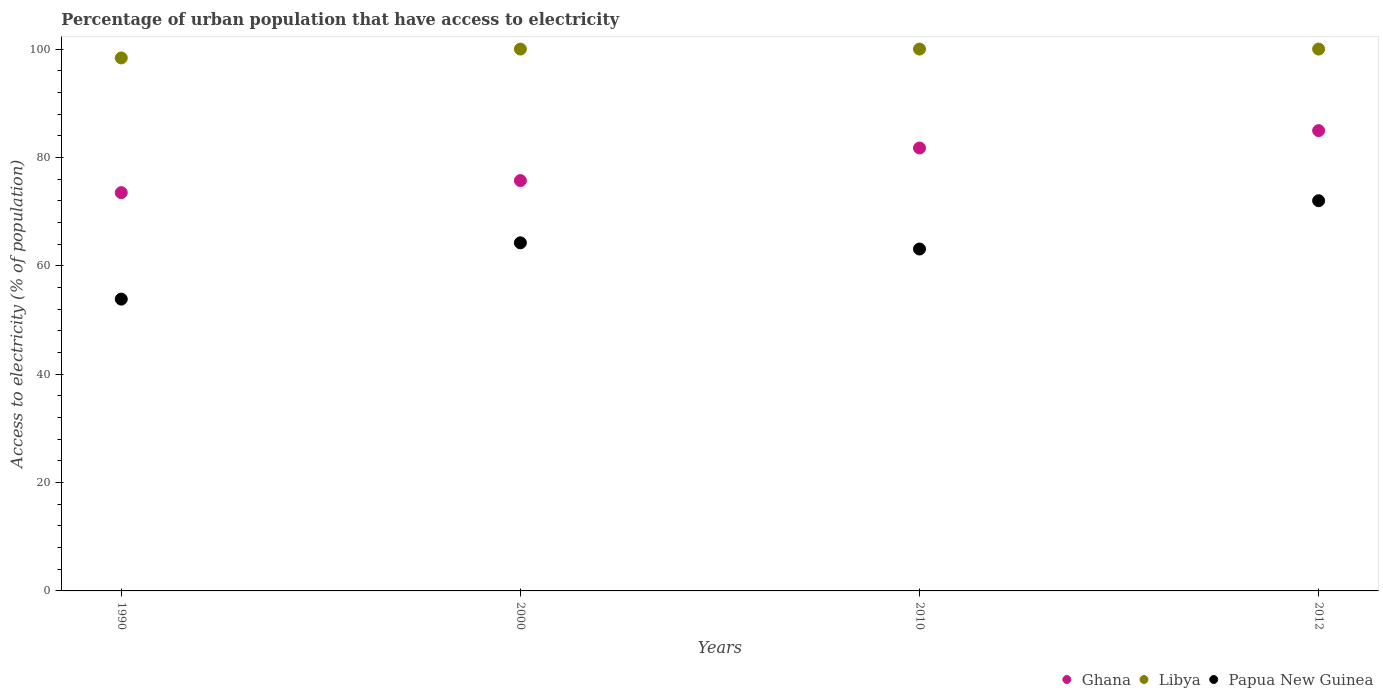How many different coloured dotlines are there?
Make the answer very short. 3. What is the percentage of urban population that have access to electricity in Papua New Guinea in 2010?
Your answer should be very brief. 63.1. Across all years, what is the maximum percentage of urban population that have access to electricity in Ghana?
Offer a terse response. 84.95. Across all years, what is the minimum percentage of urban population that have access to electricity in Ghana?
Offer a terse response. 73.51. In which year was the percentage of urban population that have access to electricity in Libya maximum?
Your answer should be very brief. 2000. In which year was the percentage of urban population that have access to electricity in Ghana minimum?
Your answer should be very brief. 1990. What is the total percentage of urban population that have access to electricity in Ghana in the graph?
Make the answer very short. 315.93. What is the difference between the percentage of urban population that have access to electricity in Ghana in 1990 and that in 2010?
Provide a succinct answer. -8.24. What is the difference between the percentage of urban population that have access to electricity in Ghana in 2000 and the percentage of urban population that have access to electricity in Papua New Guinea in 2010?
Ensure brevity in your answer.  12.63. What is the average percentage of urban population that have access to electricity in Papua New Guinea per year?
Keep it short and to the point. 63.3. In the year 1990, what is the difference between the percentage of urban population that have access to electricity in Libya and percentage of urban population that have access to electricity in Papua New Guinea?
Offer a terse response. 44.51. In how many years, is the percentage of urban population that have access to electricity in Papua New Guinea greater than 40 %?
Provide a short and direct response. 4. What is the ratio of the percentage of urban population that have access to electricity in Papua New Guinea in 1990 to that in 2010?
Offer a terse response. 0.85. What is the difference between the highest and the second highest percentage of urban population that have access to electricity in Libya?
Ensure brevity in your answer.  0. What is the difference between the highest and the lowest percentage of urban population that have access to electricity in Papua New Guinea?
Ensure brevity in your answer.  18.16. Is the sum of the percentage of urban population that have access to electricity in Ghana in 1990 and 2012 greater than the maximum percentage of urban population that have access to electricity in Libya across all years?
Your answer should be compact. Yes. Does the percentage of urban population that have access to electricity in Libya monotonically increase over the years?
Make the answer very short. No. How many years are there in the graph?
Ensure brevity in your answer.  4. What is the difference between two consecutive major ticks on the Y-axis?
Your response must be concise. 20. Are the values on the major ticks of Y-axis written in scientific E-notation?
Offer a very short reply. No. Does the graph contain any zero values?
Your response must be concise. No. Does the graph contain grids?
Your response must be concise. No. How many legend labels are there?
Your answer should be compact. 3. How are the legend labels stacked?
Provide a succinct answer. Horizontal. What is the title of the graph?
Offer a very short reply. Percentage of urban population that have access to electricity. What is the label or title of the Y-axis?
Keep it short and to the point. Access to electricity (% of population). What is the Access to electricity (% of population) of Ghana in 1990?
Provide a short and direct response. 73.51. What is the Access to electricity (% of population) of Libya in 1990?
Ensure brevity in your answer.  98.37. What is the Access to electricity (% of population) in Papua New Guinea in 1990?
Offer a terse response. 53.85. What is the Access to electricity (% of population) in Ghana in 2000?
Provide a succinct answer. 75.73. What is the Access to electricity (% of population) of Papua New Guinea in 2000?
Give a very brief answer. 64.25. What is the Access to electricity (% of population) in Ghana in 2010?
Provide a short and direct response. 81.74. What is the Access to electricity (% of population) of Papua New Guinea in 2010?
Make the answer very short. 63.1. What is the Access to electricity (% of population) in Ghana in 2012?
Make the answer very short. 84.95. What is the Access to electricity (% of population) of Libya in 2012?
Your answer should be very brief. 100. What is the Access to electricity (% of population) of Papua New Guinea in 2012?
Your response must be concise. 72.01. Across all years, what is the maximum Access to electricity (% of population) of Ghana?
Make the answer very short. 84.95. Across all years, what is the maximum Access to electricity (% of population) of Papua New Guinea?
Provide a short and direct response. 72.01. Across all years, what is the minimum Access to electricity (% of population) of Ghana?
Make the answer very short. 73.51. Across all years, what is the minimum Access to electricity (% of population) in Libya?
Keep it short and to the point. 98.37. Across all years, what is the minimum Access to electricity (% of population) in Papua New Guinea?
Ensure brevity in your answer.  53.85. What is the total Access to electricity (% of population) of Ghana in the graph?
Provide a succinct answer. 315.93. What is the total Access to electricity (% of population) of Libya in the graph?
Your answer should be very brief. 398.37. What is the total Access to electricity (% of population) in Papua New Guinea in the graph?
Give a very brief answer. 253.22. What is the difference between the Access to electricity (% of population) of Ghana in 1990 and that in 2000?
Offer a terse response. -2.22. What is the difference between the Access to electricity (% of population) of Libya in 1990 and that in 2000?
Your response must be concise. -1.63. What is the difference between the Access to electricity (% of population) of Papua New Guinea in 1990 and that in 2000?
Your answer should be very brief. -10.39. What is the difference between the Access to electricity (% of population) of Ghana in 1990 and that in 2010?
Your answer should be compact. -8.24. What is the difference between the Access to electricity (% of population) of Libya in 1990 and that in 2010?
Keep it short and to the point. -1.63. What is the difference between the Access to electricity (% of population) in Papua New Guinea in 1990 and that in 2010?
Offer a very short reply. -9.25. What is the difference between the Access to electricity (% of population) of Ghana in 1990 and that in 2012?
Provide a short and direct response. -11.45. What is the difference between the Access to electricity (% of population) in Libya in 1990 and that in 2012?
Keep it short and to the point. -1.63. What is the difference between the Access to electricity (% of population) in Papua New Guinea in 1990 and that in 2012?
Provide a short and direct response. -18.16. What is the difference between the Access to electricity (% of population) in Ghana in 2000 and that in 2010?
Provide a succinct answer. -6.01. What is the difference between the Access to electricity (% of population) of Papua New Guinea in 2000 and that in 2010?
Offer a terse response. 1.14. What is the difference between the Access to electricity (% of population) in Ghana in 2000 and that in 2012?
Your response must be concise. -9.22. What is the difference between the Access to electricity (% of population) in Libya in 2000 and that in 2012?
Provide a short and direct response. 0. What is the difference between the Access to electricity (% of population) of Papua New Guinea in 2000 and that in 2012?
Provide a succinct answer. -7.77. What is the difference between the Access to electricity (% of population) in Ghana in 2010 and that in 2012?
Your answer should be compact. -3.21. What is the difference between the Access to electricity (% of population) of Libya in 2010 and that in 2012?
Offer a very short reply. 0. What is the difference between the Access to electricity (% of population) of Papua New Guinea in 2010 and that in 2012?
Keep it short and to the point. -8.91. What is the difference between the Access to electricity (% of population) of Ghana in 1990 and the Access to electricity (% of population) of Libya in 2000?
Give a very brief answer. -26.49. What is the difference between the Access to electricity (% of population) of Ghana in 1990 and the Access to electricity (% of population) of Papua New Guinea in 2000?
Ensure brevity in your answer.  9.26. What is the difference between the Access to electricity (% of population) of Libya in 1990 and the Access to electricity (% of population) of Papua New Guinea in 2000?
Provide a short and direct response. 34.12. What is the difference between the Access to electricity (% of population) of Ghana in 1990 and the Access to electricity (% of population) of Libya in 2010?
Offer a terse response. -26.49. What is the difference between the Access to electricity (% of population) in Ghana in 1990 and the Access to electricity (% of population) in Papua New Guinea in 2010?
Make the answer very short. 10.4. What is the difference between the Access to electricity (% of population) in Libya in 1990 and the Access to electricity (% of population) in Papua New Guinea in 2010?
Your answer should be compact. 35.27. What is the difference between the Access to electricity (% of population) in Ghana in 1990 and the Access to electricity (% of population) in Libya in 2012?
Offer a terse response. -26.49. What is the difference between the Access to electricity (% of population) in Ghana in 1990 and the Access to electricity (% of population) in Papua New Guinea in 2012?
Your answer should be compact. 1.49. What is the difference between the Access to electricity (% of population) of Libya in 1990 and the Access to electricity (% of population) of Papua New Guinea in 2012?
Ensure brevity in your answer.  26.35. What is the difference between the Access to electricity (% of population) of Ghana in 2000 and the Access to electricity (% of population) of Libya in 2010?
Your answer should be compact. -24.27. What is the difference between the Access to electricity (% of population) in Ghana in 2000 and the Access to electricity (% of population) in Papua New Guinea in 2010?
Provide a short and direct response. 12.63. What is the difference between the Access to electricity (% of population) in Libya in 2000 and the Access to electricity (% of population) in Papua New Guinea in 2010?
Your response must be concise. 36.9. What is the difference between the Access to electricity (% of population) in Ghana in 2000 and the Access to electricity (% of population) in Libya in 2012?
Give a very brief answer. -24.27. What is the difference between the Access to electricity (% of population) of Ghana in 2000 and the Access to electricity (% of population) of Papua New Guinea in 2012?
Your response must be concise. 3.72. What is the difference between the Access to electricity (% of population) of Libya in 2000 and the Access to electricity (% of population) of Papua New Guinea in 2012?
Give a very brief answer. 27.99. What is the difference between the Access to electricity (% of population) of Ghana in 2010 and the Access to electricity (% of population) of Libya in 2012?
Offer a very short reply. -18.26. What is the difference between the Access to electricity (% of population) in Ghana in 2010 and the Access to electricity (% of population) in Papua New Guinea in 2012?
Your response must be concise. 9.73. What is the difference between the Access to electricity (% of population) in Libya in 2010 and the Access to electricity (% of population) in Papua New Guinea in 2012?
Provide a succinct answer. 27.99. What is the average Access to electricity (% of population) in Ghana per year?
Ensure brevity in your answer.  78.98. What is the average Access to electricity (% of population) of Libya per year?
Provide a succinct answer. 99.59. What is the average Access to electricity (% of population) of Papua New Guinea per year?
Offer a terse response. 63.3. In the year 1990, what is the difference between the Access to electricity (% of population) of Ghana and Access to electricity (% of population) of Libya?
Offer a very short reply. -24.86. In the year 1990, what is the difference between the Access to electricity (% of population) in Ghana and Access to electricity (% of population) in Papua New Guinea?
Your answer should be compact. 19.65. In the year 1990, what is the difference between the Access to electricity (% of population) in Libya and Access to electricity (% of population) in Papua New Guinea?
Make the answer very short. 44.51. In the year 2000, what is the difference between the Access to electricity (% of population) of Ghana and Access to electricity (% of population) of Libya?
Offer a very short reply. -24.27. In the year 2000, what is the difference between the Access to electricity (% of population) in Ghana and Access to electricity (% of population) in Papua New Guinea?
Keep it short and to the point. 11.48. In the year 2000, what is the difference between the Access to electricity (% of population) of Libya and Access to electricity (% of population) of Papua New Guinea?
Offer a very short reply. 35.76. In the year 2010, what is the difference between the Access to electricity (% of population) of Ghana and Access to electricity (% of population) of Libya?
Offer a terse response. -18.26. In the year 2010, what is the difference between the Access to electricity (% of population) in Ghana and Access to electricity (% of population) in Papua New Guinea?
Make the answer very short. 18.64. In the year 2010, what is the difference between the Access to electricity (% of population) of Libya and Access to electricity (% of population) of Papua New Guinea?
Your answer should be very brief. 36.9. In the year 2012, what is the difference between the Access to electricity (% of population) of Ghana and Access to electricity (% of population) of Libya?
Your answer should be compact. -15.05. In the year 2012, what is the difference between the Access to electricity (% of population) in Ghana and Access to electricity (% of population) in Papua New Guinea?
Your response must be concise. 12.94. In the year 2012, what is the difference between the Access to electricity (% of population) of Libya and Access to electricity (% of population) of Papua New Guinea?
Your answer should be compact. 27.99. What is the ratio of the Access to electricity (% of population) in Ghana in 1990 to that in 2000?
Offer a very short reply. 0.97. What is the ratio of the Access to electricity (% of population) of Libya in 1990 to that in 2000?
Keep it short and to the point. 0.98. What is the ratio of the Access to electricity (% of population) of Papua New Guinea in 1990 to that in 2000?
Make the answer very short. 0.84. What is the ratio of the Access to electricity (% of population) of Ghana in 1990 to that in 2010?
Give a very brief answer. 0.9. What is the ratio of the Access to electricity (% of population) in Libya in 1990 to that in 2010?
Provide a short and direct response. 0.98. What is the ratio of the Access to electricity (% of population) in Papua New Guinea in 1990 to that in 2010?
Your answer should be compact. 0.85. What is the ratio of the Access to electricity (% of population) of Ghana in 1990 to that in 2012?
Ensure brevity in your answer.  0.87. What is the ratio of the Access to electricity (% of population) of Libya in 1990 to that in 2012?
Keep it short and to the point. 0.98. What is the ratio of the Access to electricity (% of population) in Papua New Guinea in 1990 to that in 2012?
Ensure brevity in your answer.  0.75. What is the ratio of the Access to electricity (% of population) in Ghana in 2000 to that in 2010?
Your response must be concise. 0.93. What is the ratio of the Access to electricity (% of population) in Papua New Guinea in 2000 to that in 2010?
Your answer should be compact. 1.02. What is the ratio of the Access to electricity (% of population) of Ghana in 2000 to that in 2012?
Give a very brief answer. 0.89. What is the ratio of the Access to electricity (% of population) in Libya in 2000 to that in 2012?
Offer a very short reply. 1. What is the ratio of the Access to electricity (% of population) in Papua New Guinea in 2000 to that in 2012?
Provide a succinct answer. 0.89. What is the ratio of the Access to electricity (% of population) of Ghana in 2010 to that in 2012?
Provide a succinct answer. 0.96. What is the ratio of the Access to electricity (% of population) of Papua New Guinea in 2010 to that in 2012?
Make the answer very short. 0.88. What is the difference between the highest and the second highest Access to electricity (% of population) in Ghana?
Provide a short and direct response. 3.21. What is the difference between the highest and the second highest Access to electricity (% of population) of Papua New Guinea?
Make the answer very short. 7.77. What is the difference between the highest and the lowest Access to electricity (% of population) of Ghana?
Offer a very short reply. 11.45. What is the difference between the highest and the lowest Access to electricity (% of population) in Libya?
Offer a terse response. 1.63. What is the difference between the highest and the lowest Access to electricity (% of population) in Papua New Guinea?
Provide a succinct answer. 18.16. 